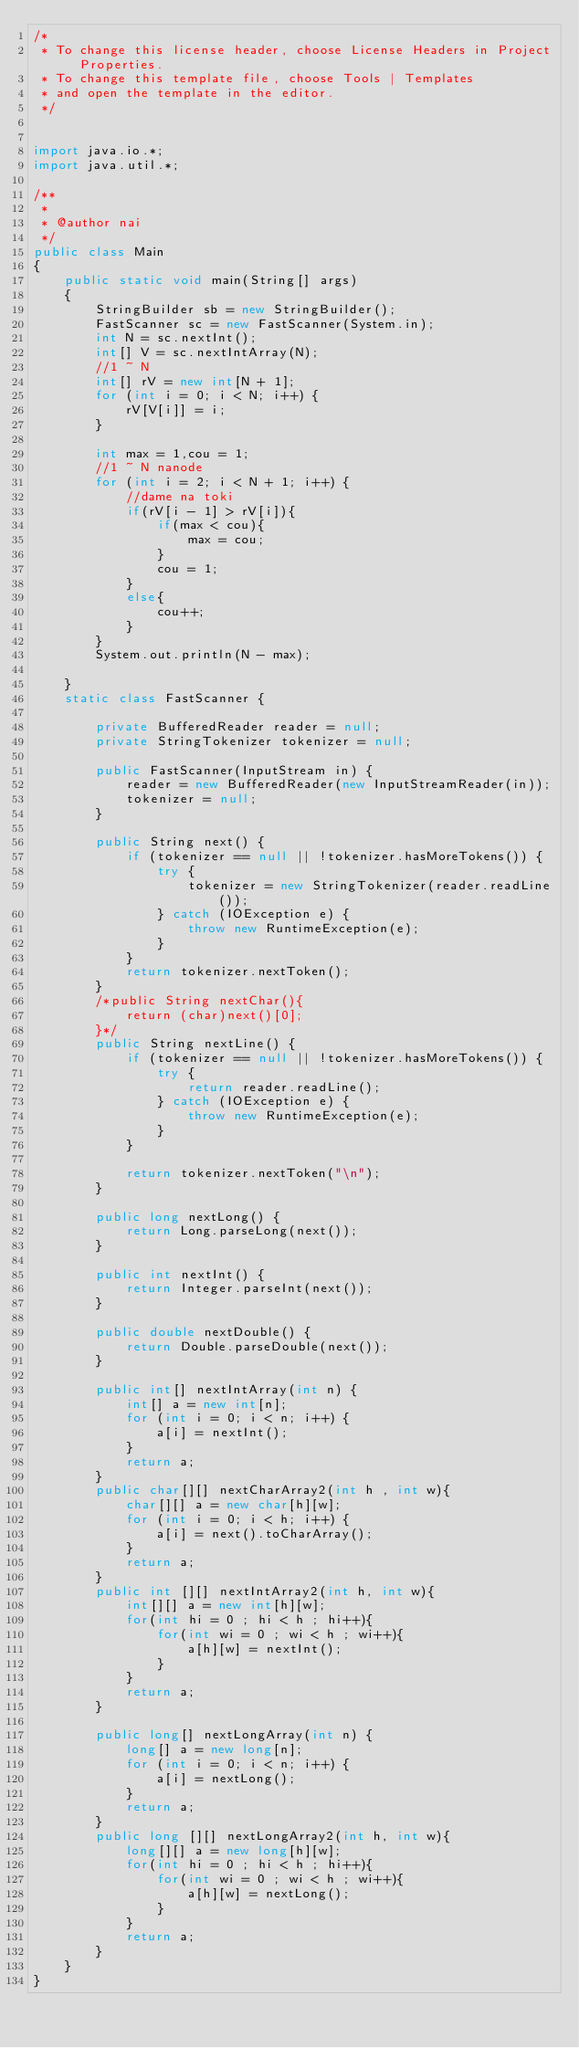<code> <loc_0><loc_0><loc_500><loc_500><_Java_>/*
 * To change this license header, choose License Headers in Project Properties.
 * To change this template file, choose Tools | Templates
 * and open the template in the editor.
 */


import java.io.*;
import java.util.*;

/**
 *
 * @author nai
 */
public class Main
{
    public static void main(String[] args)
    {
        StringBuilder sb = new StringBuilder();
        FastScanner sc = new FastScanner(System.in);
        int N = sc.nextInt();
        int[] V = sc.nextIntArray(N);
        //1 ~ N
        int[] rV = new int[N + 1];
        for (int i = 0; i < N; i++) {
            rV[V[i]] = i;
        }
        
        int max = 1,cou = 1;
        //1 ~ N nanode
        for (int i = 2; i < N + 1; i++) {
            //dame na toki
            if(rV[i - 1] > rV[i]){
                if(max < cou){
                    max = cou;
                }
                cou = 1;
            }
            else{
                cou++;
            }
        }
        System.out.println(N - max);
        
    }
    static class FastScanner {

        private BufferedReader reader = null;
        private StringTokenizer tokenizer = null;
        
        public FastScanner(InputStream in) {
            reader = new BufferedReader(new InputStreamReader(in));
            tokenizer = null;
        }
        
        public String next() {
            if (tokenizer == null || !tokenizer.hasMoreTokens()) {
                try {
                    tokenizer = new StringTokenizer(reader.readLine());
                } catch (IOException e) {
                    throw new RuntimeException(e);
                }
            }
            return tokenizer.nextToken();
        }
        /*public String nextChar(){
            return (char)next()[0];
        }*/
        public String nextLine() {
            if (tokenizer == null || !tokenizer.hasMoreTokens()) {
                try {
                    return reader.readLine();
                } catch (IOException e) {
                    throw new RuntimeException(e);
                }
            }
            
            return tokenizer.nextToken("\n");
        }
        
        public long nextLong() {
            return Long.parseLong(next());
        }
        
        public int nextInt() {
            return Integer.parseInt(next());
        }
        
        public double nextDouble() {
            return Double.parseDouble(next());
        }
        
        public int[] nextIntArray(int n) {
            int[] a = new int[n];
            for (int i = 0; i < n; i++) {
                a[i] = nextInt();
            }
            return a;
        }
        public char[][] nextCharArray2(int h , int w){
            char[][] a = new char[h][w];
            for (int i = 0; i < h; i++) {
                a[i] = next().toCharArray();
            }
            return a;
        }
        public int [][] nextIntArray2(int h, int w){
            int[][] a = new int[h][w];
            for(int hi = 0 ; hi < h ; hi++){
                for(int wi = 0 ; wi < h ; wi++){
                    a[h][w] = nextInt();
                }
            }
            return a;
        }
        
        public long[] nextLongArray(int n) {
            long[] a = new long[n];
            for (int i = 0; i < n; i++) {
                a[i] = nextLong();
            }
            return a;
        }
        public long [][] nextLongArray2(int h, int w){
            long[][] a = new long[h][w];
            for(int hi = 0 ; hi < h ; hi++){
                for(int wi = 0 ; wi < h ; wi++){
                    a[h][w] = nextLong();
                }
            }
            return a;
        }
    }
}
</code> 